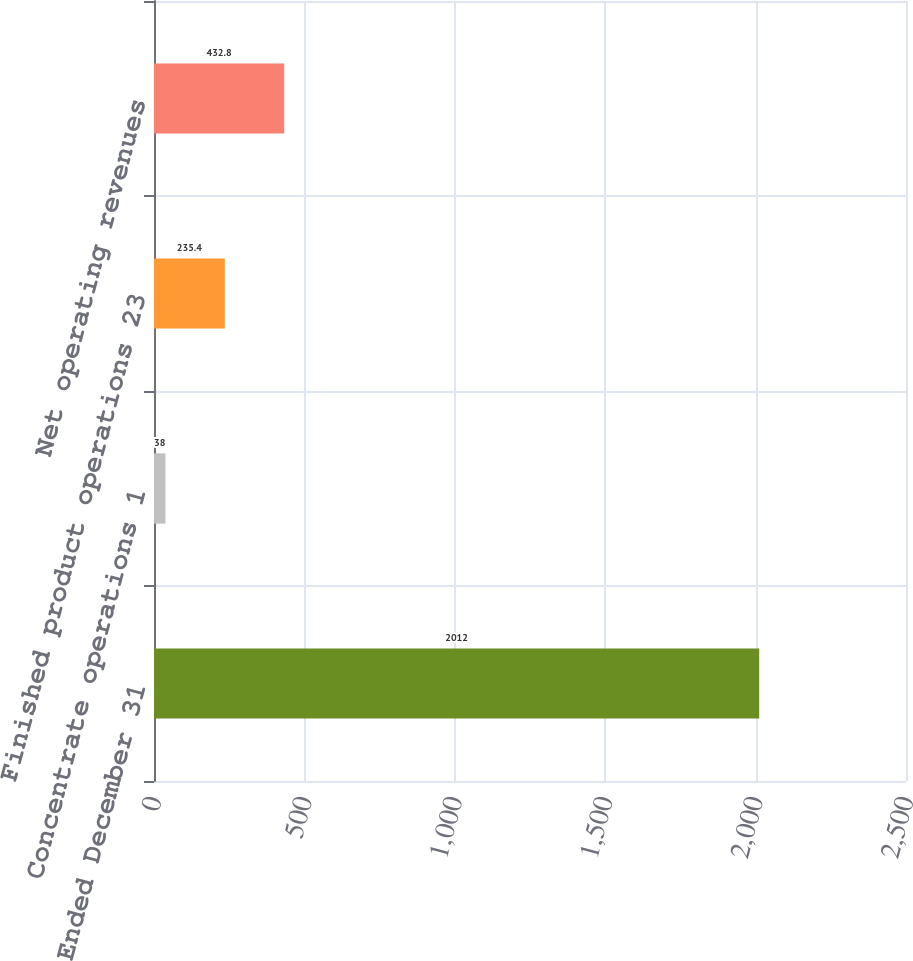Convert chart to OTSL. <chart><loc_0><loc_0><loc_500><loc_500><bar_chart><fcel>Year Ended December 31<fcel>Concentrate operations 1<fcel>Finished product operations 23<fcel>Net operating revenues<nl><fcel>2012<fcel>38<fcel>235.4<fcel>432.8<nl></chart> 